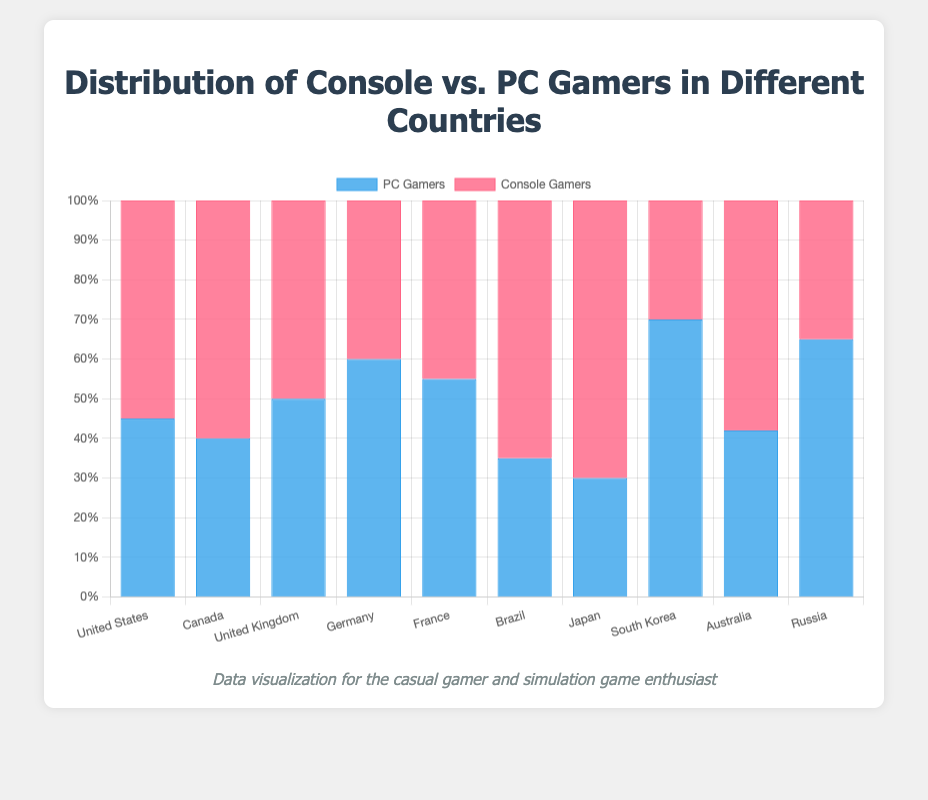Which country has the highest percentage of PC gamers? The country with the highest bar in the PC Gamers section (blue) represents the highest percentage. By examining the blue bars, South Korea has the highest percentage at 70%.
Answer: South Korea Which country has an equal percentage of PC gamers and console gamers? Look for the country where the blue and red bars are equal in height. The United Kingdom has both bars at 50%.
Answer: United Kingdom Which country has the widest gap in percentage between console gamers and PC gamers? Calculate the difference between the percentages for each country and identify the largest gap. Japan has the largest difference with 70% console gamers and 30% PC gamers, giving a gap of 40%.
Answer: Japan What is the average percentage of PC gamers across all countries? Sum all the PC Gamers percentages and divide by the number of countries. (45+40+50+60+55+35+30+70+42+65)/10 = 49.2%.
Answer: 49.2% Which countries have more console gamers than PC gamers? Identify the countries where the red bars (console gamers) are taller than the blue bars (PC gamers). These countries are the United States, Canada, Brazil, Japan, and Australia.
Answer: United States, Canada, Brazil, Japan, Australia What is the difference in percentage between PC gamers in Germany and France? Subtract the percentage of PC gamers in France from Germany. 60% (Germany) - 55% (France) = 5%.
Answer: 5% For how many countries is the percentage of console gamers above 50%? Count the number of countries with red bars exceeding the 50% mark. There are 4 such countries: United States, Canada, Brazil, and Japan.
Answer: 4 What is the total percentage of gamers in Russia combining both PC and console gamers? Add the percentages of PC and console gamers in Russia. 65% (PC) + 35% (Console) = 100%.
Answer: 100% Which country has the smallest percentage of console gamers? Identify the country with the shortest red bar. South Korea has the smallest percentage at 30%.
Answer: South Korea Is the percentage of PC gamers higher in Canada or Australia? Compare the height of the blue bars for Canada and Australia. Canada has 40%, while Australia has 42%, so Australia has a higher percentage.
Answer: Australia 